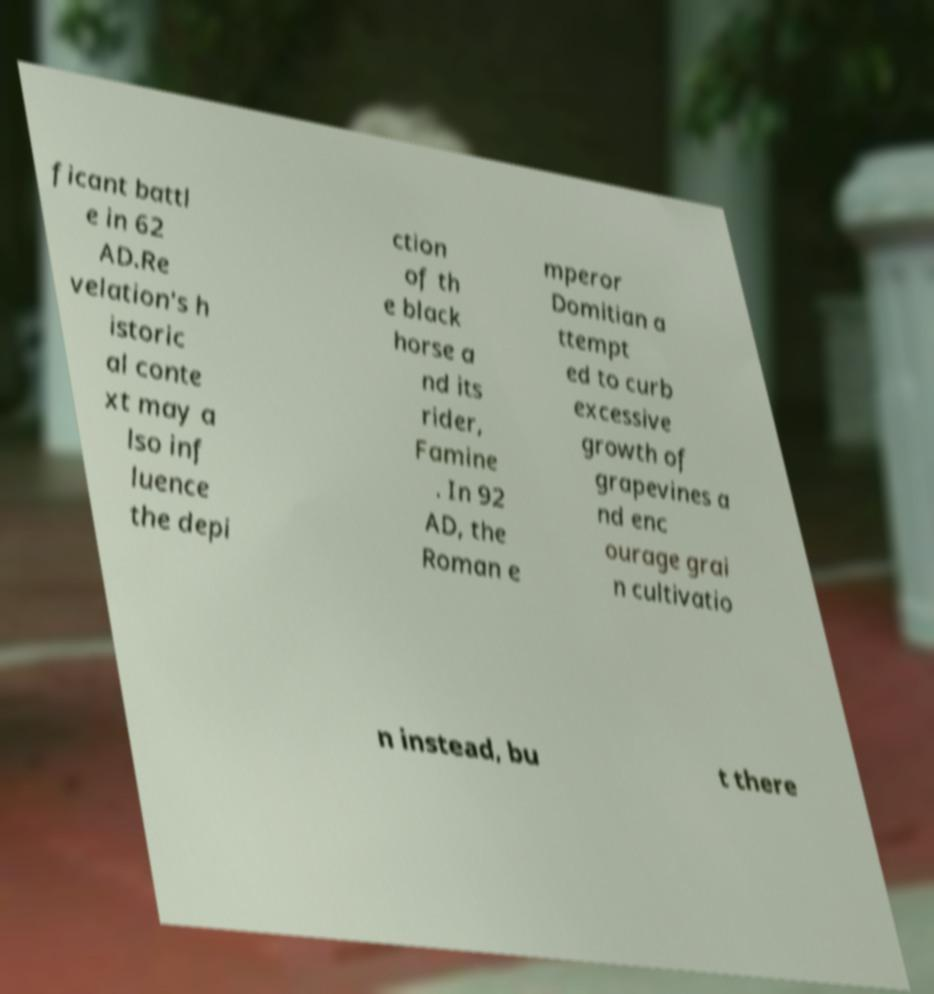What messages or text are displayed in this image? I need them in a readable, typed format. ficant battl e in 62 AD.Re velation's h istoric al conte xt may a lso inf luence the depi ction of th e black horse a nd its rider, Famine . In 92 AD, the Roman e mperor Domitian a ttempt ed to curb excessive growth of grapevines a nd enc ourage grai n cultivatio n instead, bu t there 